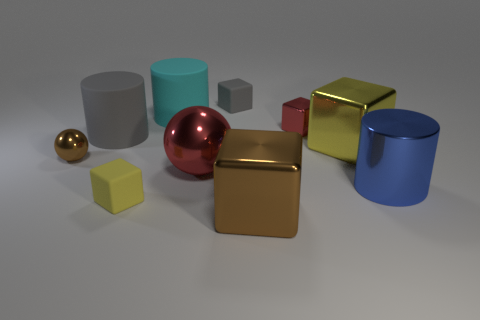How many geometric shapes can you identify here? The image presents a collection of various geometric shapes including a sphere, a cylinder, a cube, and several cuboids—each with different dimensions. All of these shapes together showcase a study of geometry and three-dimensionality. 